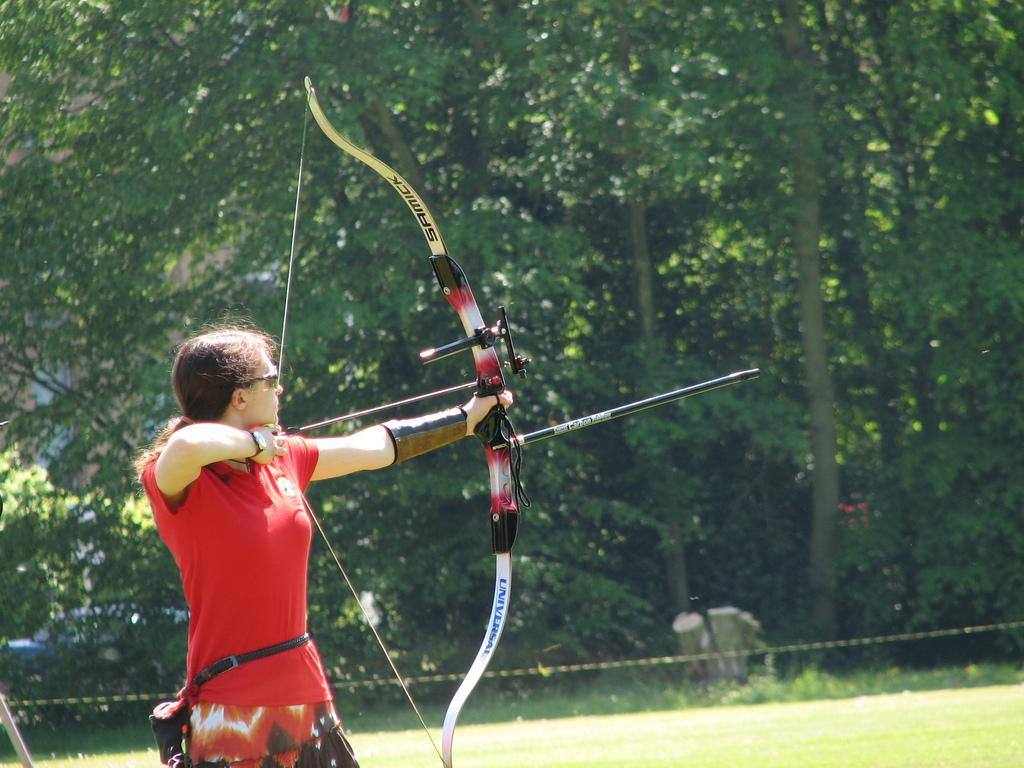Who is the main subject in the image? There is a woman in the image. What is the woman doing in the image? The woman is using a longbow and arrow. What is the woman wearing in the image? The woman is wearing a red dress. What can be seen in the background of the image? There are trees behind the woman. What type of terrain is visible in the image? The land is full of grass. What type of spot can be seen on the woman's teeth in the image? There is no mention of the woman's teeth in the image, so it is not possible to determine if there are any spots on them. 